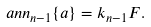Convert formula to latex. <formula><loc_0><loc_0><loc_500><loc_500>\ a n n _ { n - 1 } \{ a \} = k _ { n - 1 } F .</formula> 